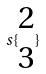<formula> <loc_0><loc_0><loc_500><loc_500>s \{ \begin{matrix} 2 \\ 3 \end{matrix} \}</formula> 